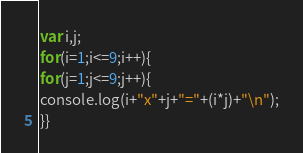Convert code to text. <code><loc_0><loc_0><loc_500><loc_500><_JavaScript_>var i,j;
for(i=1;i<=9;i++){
for(j=1;j<=9;j++){
console.log(i+"x"+j+"="+(i*j)+"\n");
}}</code> 